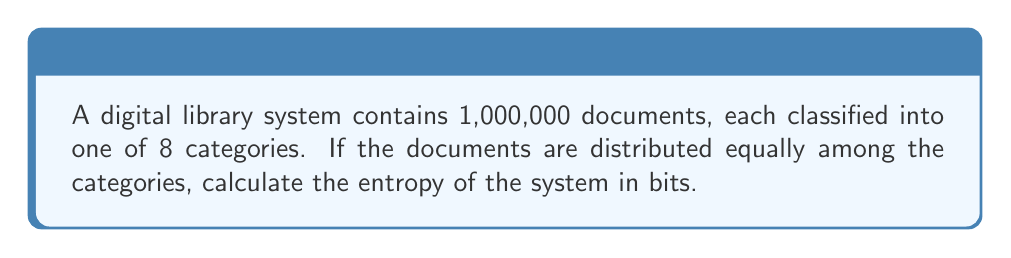Teach me how to tackle this problem. Let's approach this step-by-step:

1) In statistical mechanics, entropy is a measure of the number of possible microstates in a system. In information theory, it represents the average amount of information contained in each message received.

2) The formula for entropy in information theory is:

   $$H = -\sum_{i=1}^{n} p_i \log_2(p_i)$$

   where $p_i$ is the probability of each state.

3) In this case, we have 8 equally likely categories. So, the probability of a document being in any category is:

   $$p_i = \frac{1}{8}$$

4) Since all probabilities are equal, we can simplify our entropy formula:

   $$H = -n \cdot p \log_2(p)$$

   where $n$ is the number of categories.

5) Substituting our values:

   $$H = -8 \cdot \frac{1}{8} \log_2(\frac{1}{8})$$

6) Simplify:

   $$H = -\log_2(\frac{1}{8}) = \log_2(8) = 3$$

Therefore, the entropy of the system is 3 bits.
Answer: 3 bits 